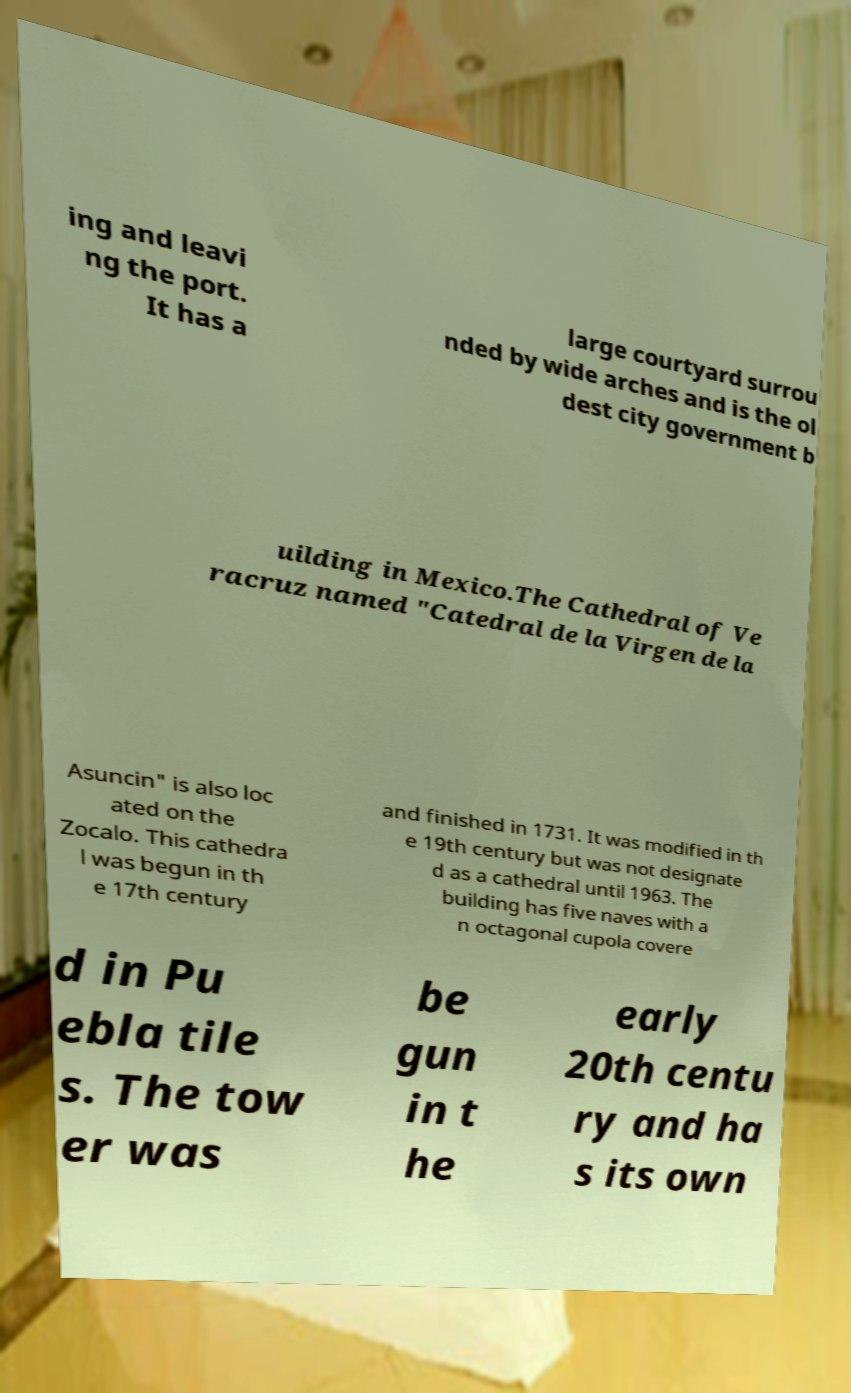What messages or text are displayed in this image? I need them in a readable, typed format. ing and leavi ng the port. It has a large courtyard surrou nded by wide arches and is the ol dest city government b uilding in Mexico.The Cathedral of Ve racruz named "Catedral de la Virgen de la Asuncin" is also loc ated on the Zocalo. This cathedra l was begun in th e 17th century and finished in 1731. It was modified in th e 19th century but was not designate d as a cathedral until 1963. The building has five naves with a n octagonal cupola covere d in Pu ebla tile s. The tow er was be gun in t he early 20th centu ry and ha s its own 